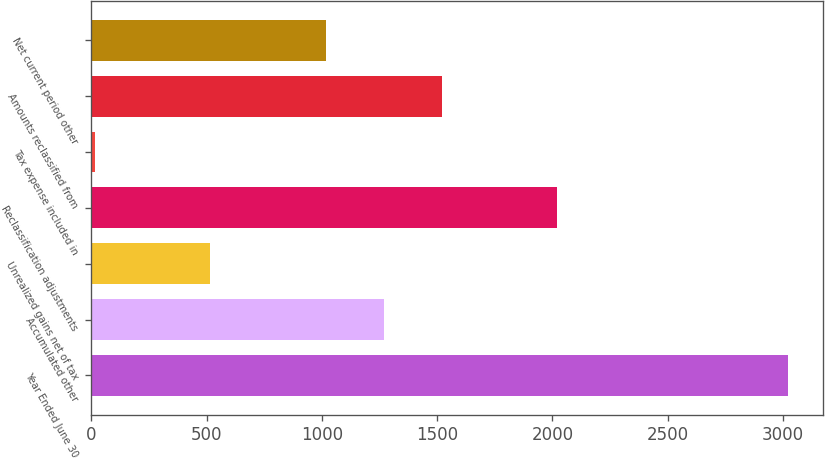Convert chart. <chart><loc_0><loc_0><loc_500><loc_500><bar_chart><fcel>Year Ended June 30<fcel>Accumulated other<fcel>Unrealized gains net of tax<fcel>Reclassification adjustments<fcel>Tax expense included in<fcel>Amounts reclassified from<fcel>Net current period other<nl><fcel>3023.4<fcel>1268.5<fcel>516.4<fcel>2020.6<fcel>15<fcel>1519.2<fcel>1017.8<nl></chart> 